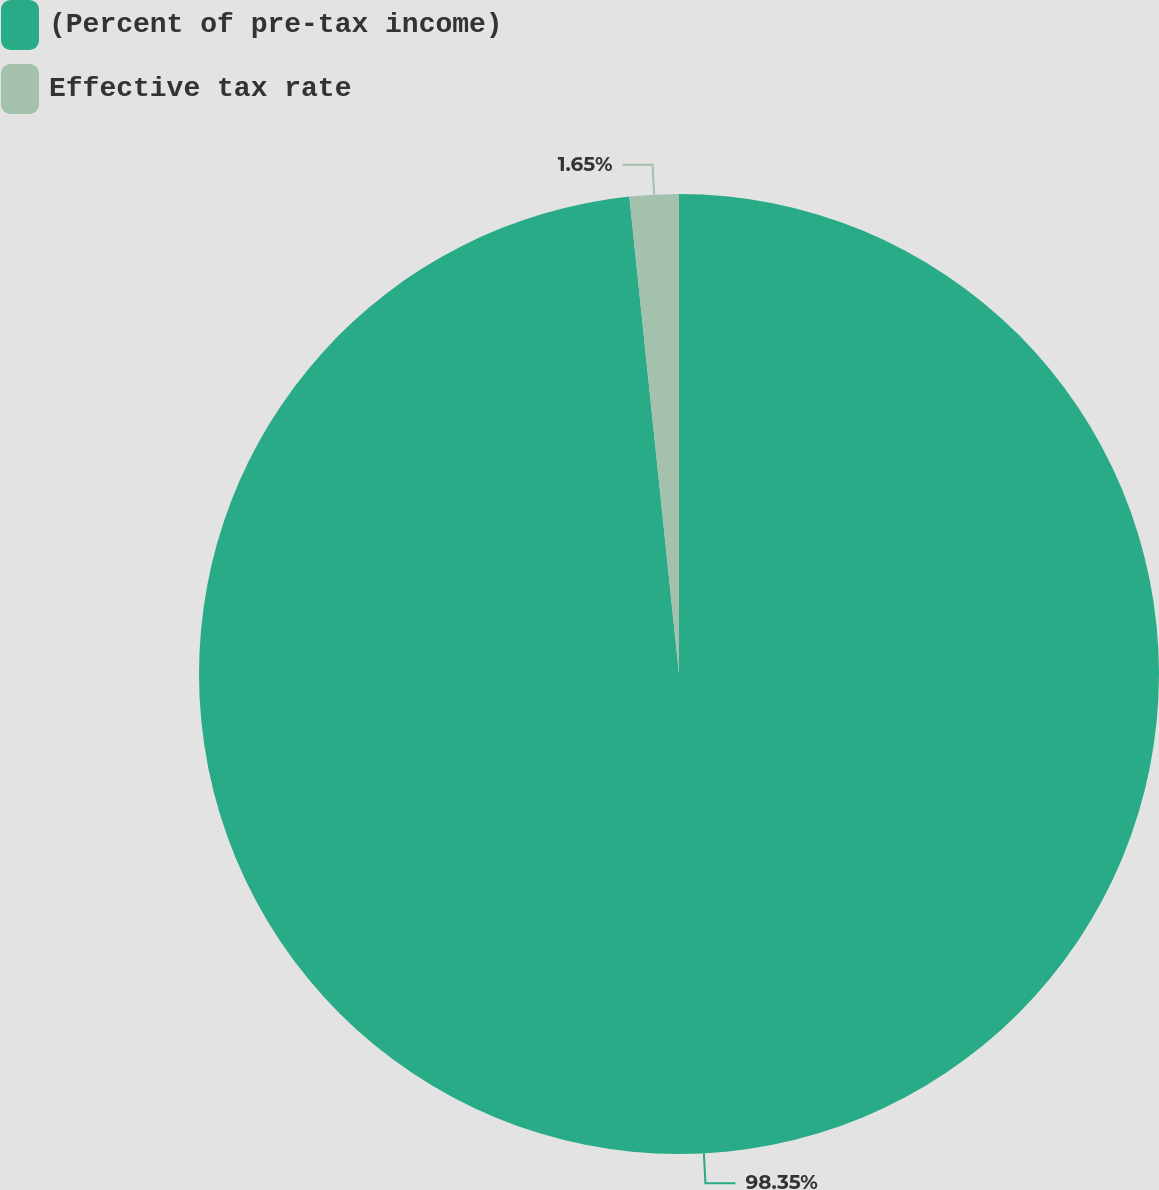Convert chart. <chart><loc_0><loc_0><loc_500><loc_500><pie_chart><fcel>(Percent of pre-tax income)<fcel>Effective tax rate<nl><fcel>98.35%<fcel>1.65%<nl></chart> 